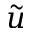Convert formula to latex. <formula><loc_0><loc_0><loc_500><loc_500>\tilde { u }</formula> 